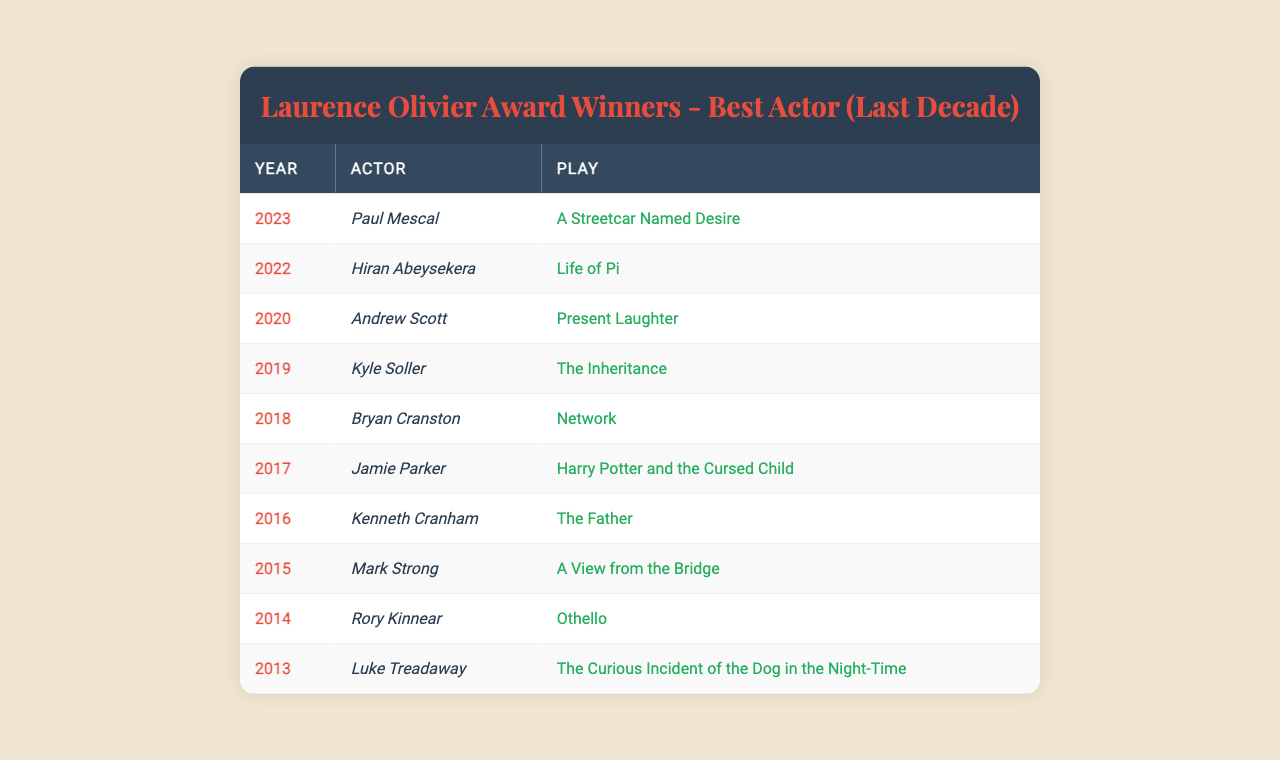What year did Paul Mescal win the award? The table shows that Paul Mescal won the award in 2023.
Answer: 2023 Who won the award in 2020? According to the table, Andrew Scott won the award in 2020.
Answer: Andrew Scott Which play did Hiran Abeysekera perform in to win the award? The table indicates that Hiran Abeysekera won the award for his performance in "Life of Pi".
Answer: Life of Pi How many different actors won the award from 2014 to 2023? The table lists 10 different actors as winners from 2014 to 2023, which can be counted directly.
Answer: 10 Did any actor win the award more than once in this decade? The table shows one winner for each year, indicating that no actor is listed as winning more than once.
Answer: No In which year did Bryan Cranston win the award? The table shows that Bryan Cranston won the award in 2018.
Answer: 2018 What was the title of the play performed by Luke Treadaway? According to the table, Luke Treadaway performed in "The Curious Incident of the Dog in the Night-Time".
Answer: The Curious Incident of the Dog in the Night-Time Which actor won the award for the play "Othello"? The table indicates that Rory Kinnear won the award for "Othello".
Answer: Rory Kinnear What is the average year of the award winners in the last decade? To find the average year, sum the years from 2013 to 2023 (2013 + 2014 + 2015 + 2016 + 2017 + 2018 + 2019 + 2020 + 2021 + 2022 + 2023) and divide by 10, which equals 2018.
Answer: 2018 List the names of the winners along with their corresponding plays. The table provides a list of winners and their plays from 2013 to 2023, which can be compiled directly.
Answer: Paul Mescal - A Streetcar Named Desire, Hiran Abeysekera - Life of Pi, Andrew Scott - Present Laughter, Kyle Soller - The Inheritance, Bryan Cranston - Network, Jamie Parker - Harry Potter and the Cursed Child, Kenneth Cranham - The Father, Mark Strong - A View from the Bridge, Rory Kinnear - Othello, Luke Treadaway - The Curious Incident of the Dog in the Night-Time 